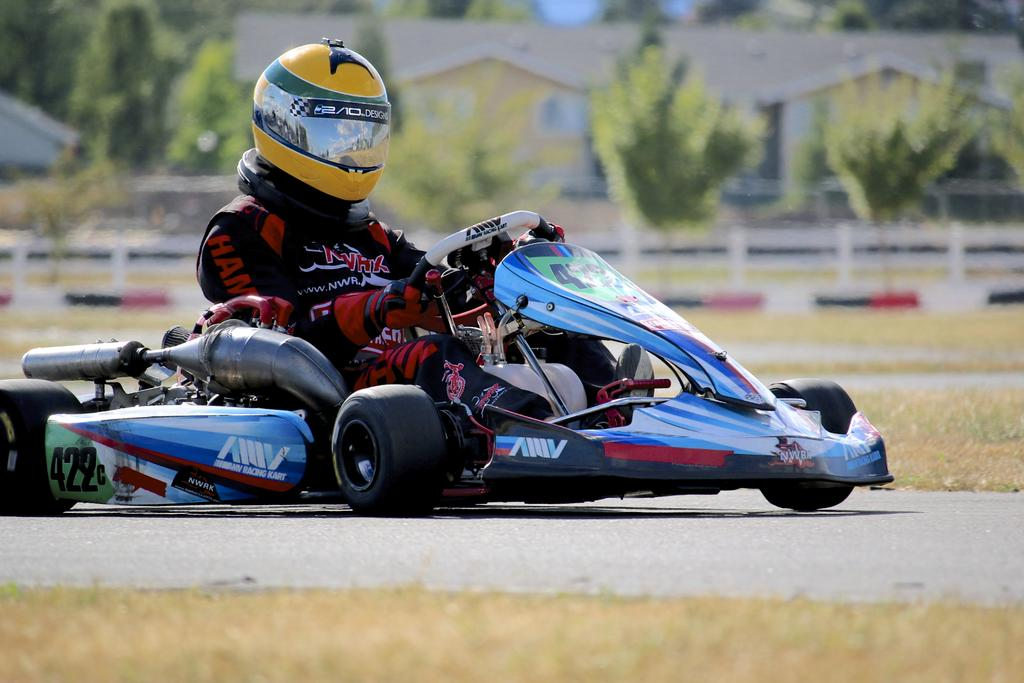What is the main subject of the image? There is a person driving a racing car in the image. Where is the car located? The car is on the road in the image. What type of vegetation can be seen in the image? There is grass visible in the image. What structures can be seen in the image? There is a fence, trees, and a building in the image. What type of gun is the person holding while driving the racing car in the image? There is no gun present in the image; the person is driving a racing car. What is the person's desire while driving the racing car in the image? The image does not provide information about the person's desires or intentions while driving the racing car. --- Facts: 1. There is a person holding a book in the image. 2. The person is sitting on a chair. 3. There is a table in the image. 4. The table has a lamp on it. 5. There is a window in the image. Absurd Topics: elephant, ocean, dance Conversation: What is the person in the image doing? The person is holding a book in the image. Where is the person sitting? The person is sitting on a chair in the image. What is on the table in the image? The table has a lamp on it in the image. What can be seen through the window in the image? The image does not provide information about what can be seen through the window. Reasoning: Let's think step by step in order to produce the conversation. We start by identifying the main subject of the image, which is the person holding a book. Then, we describe the person's location and the objects around them, including the chair, table, and lamp. Each question is designed to elicit a specific detail about the image that is known from the provided facts. Absurd Question/Answer: Can you see an elephant swimming in the ocean in the image? There is no elephant or ocean present in the image. Is the person dancing while holding the book in the image? The image does not provide information about the person dancing or any other movements while holding the book. 